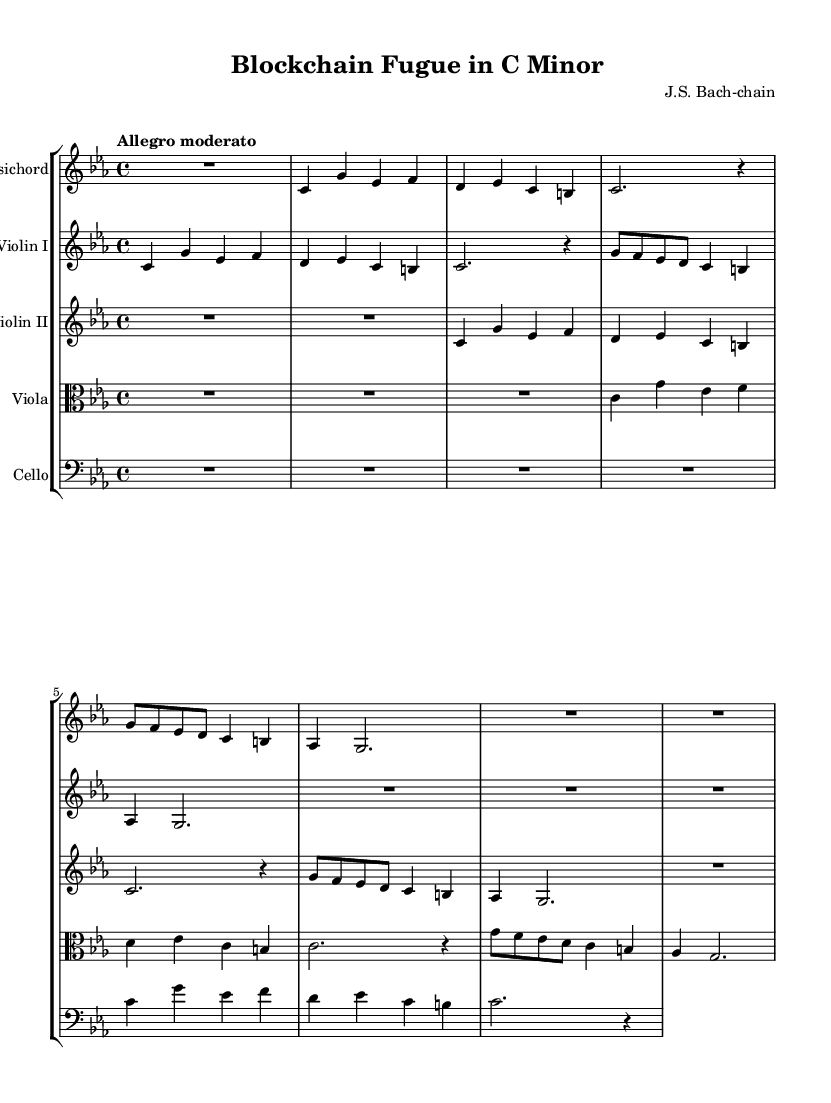What is the key signature of this music? The key signature is C minor, which has three flats: B flat, E flat, and A flat.
Answer: C minor What is the time signature of the piece? The time signature is indicated at the beginning and is 4/4, meaning there are four beats in a measure.
Answer: 4/4 What is the tempo marking for this piece? The tempo marking shows "Allegro moderato," which suggests a moderately fast pace.
Answer: Allegro moderato How many measures are in the Harpsichord part? To determine this, count the distinct sections separated by bar lines in the Harpsichord part. There are a total of 9 measures.
Answer: 9 What instruments are included in this composition? The instruments are listed at the beginning of each staff: Harpsichord, Violin I, Violin II, Viola, and Cello.
Answer: Harpsichord, Violin I, Violin II, Viola, Cello Is there a counterpoint involving more than two voices? The sheet music shows a complex interweaving of parts that demonstrates counterpoint, particularly between multiple string instruments and the Harpsichord.
Answer: Yes How many distinct themes can be identified in the composition? The composition presents two distinct themes: the subject and the counter-subject, each performed by various instruments.
Answer: Two 